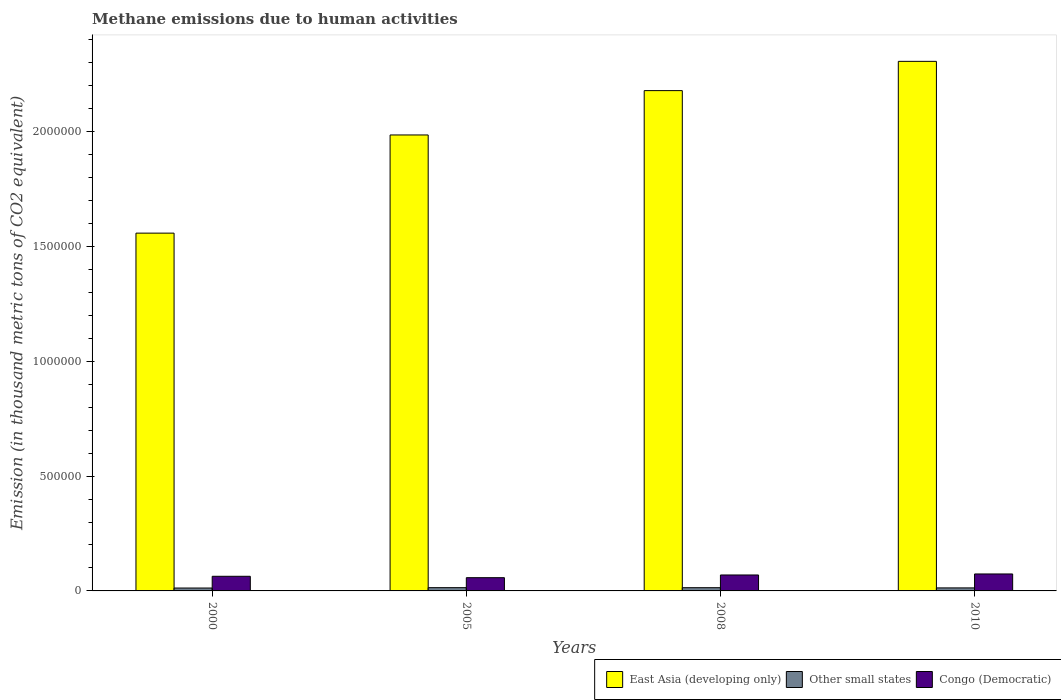How many groups of bars are there?
Offer a very short reply. 4. How many bars are there on the 4th tick from the right?
Make the answer very short. 3. In how many cases, is the number of bars for a given year not equal to the number of legend labels?
Offer a terse response. 0. What is the amount of methane emitted in East Asia (developing only) in 2008?
Your response must be concise. 2.18e+06. Across all years, what is the maximum amount of methane emitted in Congo (Democratic)?
Offer a terse response. 7.39e+04. Across all years, what is the minimum amount of methane emitted in East Asia (developing only)?
Provide a succinct answer. 1.56e+06. In which year was the amount of methane emitted in East Asia (developing only) minimum?
Provide a succinct answer. 2000. What is the total amount of methane emitted in East Asia (developing only) in the graph?
Ensure brevity in your answer.  8.03e+06. What is the difference between the amount of methane emitted in East Asia (developing only) in 2000 and that in 2008?
Provide a short and direct response. -6.20e+05. What is the difference between the amount of methane emitted in East Asia (developing only) in 2010 and the amount of methane emitted in Congo (Democratic) in 2005?
Ensure brevity in your answer.  2.25e+06. What is the average amount of methane emitted in Congo (Democratic) per year?
Your answer should be compact. 6.62e+04. In the year 2008, what is the difference between the amount of methane emitted in East Asia (developing only) and amount of methane emitted in Other small states?
Give a very brief answer. 2.16e+06. In how many years, is the amount of methane emitted in East Asia (developing only) greater than 2000000 thousand metric tons?
Provide a short and direct response. 2. What is the ratio of the amount of methane emitted in Congo (Democratic) in 2000 to that in 2005?
Your response must be concise. 1.1. Is the amount of methane emitted in Other small states in 2000 less than that in 2010?
Provide a short and direct response. Yes. What is the difference between the highest and the second highest amount of methane emitted in Congo (Democratic)?
Give a very brief answer. 4413.4. What is the difference between the highest and the lowest amount of methane emitted in Congo (Democratic)?
Offer a very short reply. 1.62e+04. What does the 2nd bar from the left in 2008 represents?
Give a very brief answer. Other small states. What does the 2nd bar from the right in 2005 represents?
Give a very brief answer. Other small states. Are all the bars in the graph horizontal?
Keep it short and to the point. No. How many years are there in the graph?
Make the answer very short. 4. Where does the legend appear in the graph?
Keep it short and to the point. Bottom right. How many legend labels are there?
Offer a very short reply. 3. What is the title of the graph?
Your answer should be compact. Methane emissions due to human activities. Does "Norway" appear as one of the legend labels in the graph?
Your answer should be very brief. No. What is the label or title of the X-axis?
Offer a very short reply. Years. What is the label or title of the Y-axis?
Make the answer very short. Emission (in thousand metric tons of CO2 equivalent). What is the Emission (in thousand metric tons of CO2 equivalent) in East Asia (developing only) in 2000?
Give a very brief answer. 1.56e+06. What is the Emission (in thousand metric tons of CO2 equivalent) of Other small states in 2000?
Your answer should be very brief. 1.26e+04. What is the Emission (in thousand metric tons of CO2 equivalent) in Congo (Democratic) in 2000?
Give a very brief answer. 6.37e+04. What is the Emission (in thousand metric tons of CO2 equivalent) in East Asia (developing only) in 2005?
Give a very brief answer. 1.99e+06. What is the Emission (in thousand metric tons of CO2 equivalent) in Other small states in 2005?
Provide a succinct answer. 1.42e+04. What is the Emission (in thousand metric tons of CO2 equivalent) in Congo (Democratic) in 2005?
Offer a terse response. 5.77e+04. What is the Emission (in thousand metric tons of CO2 equivalent) of East Asia (developing only) in 2008?
Your response must be concise. 2.18e+06. What is the Emission (in thousand metric tons of CO2 equivalent) in Other small states in 2008?
Offer a terse response. 1.41e+04. What is the Emission (in thousand metric tons of CO2 equivalent) in Congo (Democratic) in 2008?
Offer a very short reply. 6.94e+04. What is the Emission (in thousand metric tons of CO2 equivalent) of East Asia (developing only) in 2010?
Offer a terse response. 2.31e+06. What is the Emission (in thousand metric tons of CO2 equivalent) of Other small states in 2010?
Your response must be concise. 1.32e+04. What is the Emission (in thousand metric tons of CO2 equivalent) of Congo (Democratic) in 2010?
Provide a short and direct response. 7.39e+04. Across all years, what is the maximum Emission (in thousand metric tons of CO2 equivalent) of East Asia (developing only)?
Your answer should be very brief. 2.31e+06. Across all years, what is the maximum Emission (in thousand metric tons of CO2 equivalent) of Other small states?
Offer a very short reply. 1.42e+04. Across all years, what is the maximum Emission (in thousand metric tons of CO2 equivalent) in Congo (Democratic)?
Provide a succinct answer. 7.39e+04. Across all years, what is the minimum Emission (in thousand metric tons of CO2 equivalent) of East Asia (developing only)?
Offer a very short reply. 1.56e+06. Across all years, what is the minimum Emission (in thousand metric tons of CO2 equivalent) in Other small states?
Make the answer very short. 1.26e+04. Across all years, what is the minimum Emission (in thousand metric tons of CO2 equivalent) in Congo (Democratic)?
Ensure brevity in your answer.  5.77e+04. What is the total Emission (in thousand metric tons of CO2 equivalent) of East Asia (developing only) in the graph?
Provide a succinct answer. 8.03e+06. What is the total Emission (in thousand metric tons of CO2 equivalent) of Other small states in the graph?
Make the answer very short. 5.40e+04. What is the total Emission (in thousand metric tons of CO2 equivalent) of Congo (Democratic) in the graph?
Make the answer very short. 2.65e+05. What is the difference between the Emission (in thousand metric tons of CO2 equivalent) in East Asia (developing only) in 2000 and that in 2005?
Your response must be concise. -4.27e+05. What is the difference between the Emission (in thousand metric tons of CO2 equivalent) in Other small states in 2000 and that in 2005?
Your answer should be compact. -1602.4. What is the difference between the Emission (in thousand metric tons of CO2 equivalent) in Congo (Democratic) in 2000 and that in 2005?
Give a very brief answer. 6010.4. What is the difference between the Emission (in thousand metric tons of CO2 equivalent) of East Asia (developing only) in 2000 and that in 2008?
Offer a terse response. -6.20e+05. What is the difference between the Emission (in thousand metric tons of CO2 equivalent) of Other small states in 2000 and that in 2008?
Offer a terse response. -1460.3. What is the difference between the Emission (in thousand metric tons of CO2 equivalent) in Congo (Democratic) in 2000 and that in 2008?
Your answer should be very brief. -5750.5. What is the difference between the Emission (in thousand metric tons of CO2 equivalent) in East Asia (developing only) in 2000 and that in 2010?
Give a very brief answer. -7.48e+05. What is the difference between the Emission (in thousand metric tons of CO2 equivalent) in Other small states in 2000 and that in 2010?
Offer a very short reply. -561.8. What is the difference between the Emission (in thousand metric tons of CO2 equivalent) of Congo (Democratic) in 2000 and that in 2010?
Keep it short and to the point. -1.02e+04. What is the difference between the Emission (in thousand metric tons of CO2 equivalent) of East Asia (developing only) in 2005 and that in 2008?
Ensure brevity in your answer.  -1.93e+05. What is the difference between the Emission (in thousand metric tons of CO2 equivalent) of Other small states in 2005 and that in 2008?
Provide a short and direct response. 142.1. What is the difference between the Emission (in thousand metric tons of CO2 equivalent) of Congo (Democratic) in 2005 and that in 2008?
Your response must be concise. -1.18e+04. What is the difference between the Emission (in thousand metric tons of CO2 equivalent) in East Asia (developing only) in 2005 and that in 2010?
Provide a succinct answer. -3.20e+05. What is the difference between the Emission (in thousand metric tons of CO2 equivalent) of Other small states in 2005 and that in 2010?
Offer a very short reply. 1040.6. What is the difference between the Emission (in thousand metric tons of CO2 equivalent) of Congo (Democratic) in 2005 and that in 2010?
Offer a very short reply. -1.62e+04. What is the difference between the Emission (in thousand metric tons of CO2 equivalent) in East Asia (developing only) in 2008 and that in 2010?
Provide a short and direct response. -1.27e+05. What is the difference between the Emission (in thousand metric tons of CO2 equivalent) of Other small states in 2008 and that in 2010?
Your response must be concise. 898.5. What is the difference between the Emission (in thousand metric tons of CO2 equivalent) in Congo (Democratic) in 2008 and that in 2010?
Your response must be concise. -4413.4. What is the difference between the Emission (in thousand metric tons of CO2 equivalent) of East Asia (developing only) in 2000 and the Emission (in thousand metric tons of CO2 equivalent) of Other small states in 2005?
Provide a succinct answer. 1.54e+06. What is the difference between the Emission (in thousand metric tons of CO2 equivalent) in East Asia (developing only) in 2000 and the Emission (in thousand metric tons of CO2 equivalent) in Congo (Democratic) in 2005?
Your answer should be compact. 1.50e+06. What is the difference between the Emission (in thousand metric tons of CO2 equivalent) of Other small states in 2000 and the Emission (in thousand metric tons of CO2 equivalent) of Congo (Democratic) in 2005?
Your answer should be very brief. -4.51e+04. What is the difference between the Emission (in thousand metric tons of CO2 equivalent) of East Asia (developing only) in 2000 and the Emission (in thousand metric tons of CO2 equivalent) of Other small states in 2008?
Provide a short and direct response. 1.54e+06. What is the difference between the Emission (in thousand metric tons of CO2 equivalent) in East Asia (developing only) in 2000 and the Emission (in thousand metric tons of CO2 equivalent) in Congo (Democratic) in 2008?
Give a very brief answer. 1.49e+06. What is the difference between the Emission (in thousand metric tons of CO2 equivalent) in Other small states in 2000 and the Emission (in thousand metric tons of CO2 equivalent) in Congo (Democratic) in 2008?
Offer a very short reply. -5.68e+04. What is the difference between the Emission (in thousand metric tons of CO2 equivalent) in East Asia (developing only) in 2000 and the Emission (in thousand metric tons of CO2 equivalent) in Other small states in 2010?
Your answer should be compact. 1.54e+06. What is the difference between the Emission (in thousand metric tons of CO2 equivalent) of East Asia (developing only) in 2000 and the Emission (in thousand metric tons of CO2 equivalent) of Congo (Democratic) in 2010?
Your answer should be compact. 1.48e+06. What is the difference between the Emission (in thousand metric tons of CO2 equivalent) of Other small states in 2000 and the Emission (in thousand metric tons of CO2 equivalent) of Congo (Democratic) in 2010?
Give a very brief answer. -6.13e+04. What is the difference between the Emission (in thousand metric tons of CO2 equivalent) of East Asia (developing only) in 2005 and the Emission (in thousand metric tons of CO2 equivalent) of Other small states in 2008?
Provide a succinct answer. 1.97e+06. What is the difference between the Emission (in thousand metric tons of CO2 equivalent) of East Asia (developing only) in 2005 and the Emission (in thousand metric tons of CO2 equivalent) of Congo (Democratic) in 2008?
Ensure brevity in your answer.  1.92e+06. What is the difference between the Emission (in thousand metric tons of CO2 equivalent) of Other small states in 2005 and the Emission (in thousand metric tons of CO2 equivalent) of Congo (Democratic) in 2008?
Provide a succinct answer. -5.52e+04. What is the difference between the Emission (in thousand metric tons of CO2 equivalent) of East Asia (developing only) in 2005 and the Emission (in thousand metric tons of CO2 equivalent) of Other small states in 2010?
Give a very brief answer. 1.97e+06. What is the difference between the Emission (in thousand metric tons of CO2 equivalent) in East Asia (developing only) in 2005 and the Emission (in thousand metric tons of CO2 equivalent) in Congo (Democratic) in 2010?
Offer a terse response. 1.91e+06. What is the difference between the Emission (in thousand metric tons of CO2 equivalent) of Other small states in 2005 and the Emission (in thousand metric tons of CO2 equivalent) of Congo (Democratic) in 2010?
Make the answer very short. -5.97e+04. What is the difference between the Emission (in thousand metric tons of CO2 equivalent) of East Asia (developing only) in 2008 and the Emission (in thousand metric tons of CO2 equivalent) of Other small states in 2010?
Offer a terse response. 2.17e+06. What is the difference between the Emission (in thousand metric tons of CO2 equivalent) in East Asia (developing only) in 2008 and the Emission (in thousand metric tons of CO2 equivalent) in Congo (Democratic) in 2010?
Keep it short and to the point. 2.10e+06. What is the difference between the Emission (in thousand metric tons of CO2 equivalent) of Other small states in 2008 and the Emission (in thousand metric tons of CO2 equivalent) of Congo (Democratic) in 2010?
Offer a terse response. -5.98e+04. What is the average Emission (in thousand metric tons of CO2 equivalent) in East Asia (developing only) per year?
Ensure brevity in your answer.  2.01e+06. What is the average Emission (in thousand metric tons of CO2 equivalent) in Other small states per year?
Offer a very short reply. 1.35e+04. What is the average Emission (in thousand metric tons of CO2 equivalent) in Congo (Democratic) per year?
Offer a very short reply. 6.62e+04. In the year 2000, what is the difference between the Emission (in thousand metric tons of CO2 equivalent) of East Asia (developing only) and Emission (in thousand metric tons of CO2 equivalent) of Other small states?
Provide a succinct answer. 1.55e+06. In the year 2000, what is the difference between the Emission (in thousand metric tons of CO2 equivalent) of East Asia (developing only) and Emission (in thousand metric tons of CO2 equivalent) of Congo (Democratic)?
Provide a short and direct response. 1.49e+06. In the year 2000, what is the difference between the Emission (in thousand metric tons of CO2 equivalent) of Other small states and Emission (in thousand metric tons of CO2 equivalent) of Congo (Democratic)?
Offer a terse response. -5.11e+04. In the year 2005, what is the difference between the Emission (in thousand metric tons of CO2 equivalent) in East Asia (developing only) and Emission (in thousand metric tons of CO2 equivalent) in Other small states?
Provide a succinct answer. 1.97e+06. In the year 2005, what is the difference between the Emission (in thousand metric tons of CO2 equivalent) in East Asia (developing only) and Emission (in thousand metric tons of CO2 equivalent) in Congo (Democratic)?
Your answer should be compact. 1.93e+06. In the year 2005, what is the difference between the Emission (in thousand metric tons of CO2 equivalent) in Other small states and Emission (in thousand metric tons of CO2 equivalent) in Congo (Democratic)?
Make the answer very short. -4.35e+04. In the year 2008, what is the difference between the Emission (in thousand metric tons of CO2 equivalent) of East Asia (developing only) and Emission (in thousand metric tons of CO2 equivalent) of Other small states?
Ensure brevity in your answer.  2.16e+06. In the year 2008, what is the difference between the Emission (in thousand metric tons of CO2 equivalent) of East Asia (developing only) and Emission (in thousand metric tons of CO2 equivalent) of Congo (Democratic)?
Provide a succinct answer. 2.11e+06. In the year 2008, what is the difference between the Emission (in thousand metric tons of CO2 equivalent) in Other small states and Emission (in thousand metric tons of CO2 equivalent) in Congo (Democratic)?
Make the answer very short. -5.54e+04. In the year 2010, what is the difference between the Emission (in thousand metric tons of CO2 equivalent) in East Asia (developing only) and Emission (in thousand metric tons of CO2 equivalent) in Other small states?
Offer a very short reply. 2.29e+06. In the year 2010, what is the difference between the Emission (in thousand metric tons of CO2 equivalent) in East Asia (developing only) and Emission (in thousand metric tons of CO2 equivalent) in Congo (Democratic)?
Your response must be concise. 2.23e+06. In the year 2010, what is the difference between the Emission (in thousand metric tons of CO2 equivalent) in Other small states and Emission (in thousand metric tons of CO2 equivalent) in Congo (Democratic)?
Provide a short and direct response. -6.07e+04. What is the ratio of the Emission (in thousand metric tons of CO2 equivalent) of East Asia (developing only) in 2000 to that in 2005?
Keep it short and to the point. 0.78. What is the ratio of the Emission (in thousand metric tons of CO2 equivalent) of Other small states in 2000 to that in 2005?
Provide a short and direct response. 0.89. What is the ratio of the Emission (in thousand metric tons of CO2 equivalent) of Congo (Democratic) in 2000 to that in 2005?
Provide a succinct answer. 1.1. What is the ratio of the Emission (in thousand metric tons of CO2 equivalent) in East Asia (developing only) in 2000 to that in 2008?
Give a very brief answer. 0.72. What is the ratio of the Emission (in thousand metric tons of CO2 equivalent) in Other small states in 2000 to that in 2008?
Your answer should be very brief. 0.9. What is the ratio of the Emission (in thousand metric tons of CO2 equivalent) in Congo (Democratic) in 2000 to that in 2008?
Ensure brevity in your answer.  0.92. What is the ratio of the Emission (in thousand metric tons of CO2 equivalent) of East Asia (developing only) in 2000 to that in 2010?
Your answer should be very brief. 0.68. What is the ratio of the Emission (in thousand metric tons of CO2 equivalent) of Other small states in 2000 to that in 2010?
Provide a short and direct response. 0.96. What is the ratio of the Emission (in thousand metric tons of CO2 equivalent) of Congo (Democratic) in 2000 to that in 2010?
Provide a succinct answer. 0.86. What is the ratio of the Emission (in thousand metric tons of CO2 equivalent) in East Asia (developing only) in 2005 to that in 2008?
Offer a very short reply. 0.91. What is the ratio of the Emission (in thousand metric tons of CO2 equivalent) in Other small states in 2005 to that in 2008?
Provide a short and direct response. 1.01. What is the ratio of the Emission (in thousand metric tons of CO2 equivalent) in Congo (Democratic) in 2005 to that in 2008?
Give a very brief answer. 0.83. What is the ratio of the Emission (in thousand metric tons of CO2 equivalent) in East Asia (developing only) in 2005 to that in 2010?
Offer a very short reply. 0.86. What is the ratio of the Emission (in thousand metric tons of CO2 equivalent) in Other small states in 2005 to that in 2010?
Offer a very short reply. 1.08. What is the ratio of the Emission (in thousand metric tons of CO2 equivalent) of Congo (Democratic) in 2005 to that in 2010?
Give a very brief answer. 0.78. What is the ratio of the Emission (in thousand metric tons of CO2 equivalent) in East Asia (developing only) in 2008 to that in 2010?
Ensure brevity in your answer.  0.94. What is the ratio of the Emission (in thousand metric tons of CO2 equivalent) of Other small states in 2008 to that in 2010?
Your answer should be compact. 1.07. What is the ratio of the Emission (in thousand metric tons of CO2 equivalent) in Congo (Democratic) in 2008 to that in 2010?
Offer a terse response. 0.94. What is the difference between the highest and the second highest Emission (in thousand metric tons of CO2 equivalent) of East Asia (developing only)?
Provide a succinct answer. 1.27e+05. What is the difference between the highest and the second highest Emission (in thousand metric tons of CO2 equivalent) of Other small states?
Provide a short and direct response. 142.1. What is the difference between the highest and the second highest Emission (in thousand metric tons of CO2 equivalent) in Congo (Democratic)?
Offer a very short reply. 4413.4. What is the difference between the highest and the lowest Emission (in thousand metric tons of CO2 equivalent) in East Asia (developing only)?
Provide a short and direct response. 7.48e+05. What is the difference between the highest and the lowest Emission (in thousand metric tons of CO2 equivalent) of Other small states?
Your response must be concise. 1602.4. What is the difference between the highest and the lowest Emission (in thousand metric tons of CO2 equivalent) in Congo (Democratic)?
Your answer should be compact. 1.62e+04. 